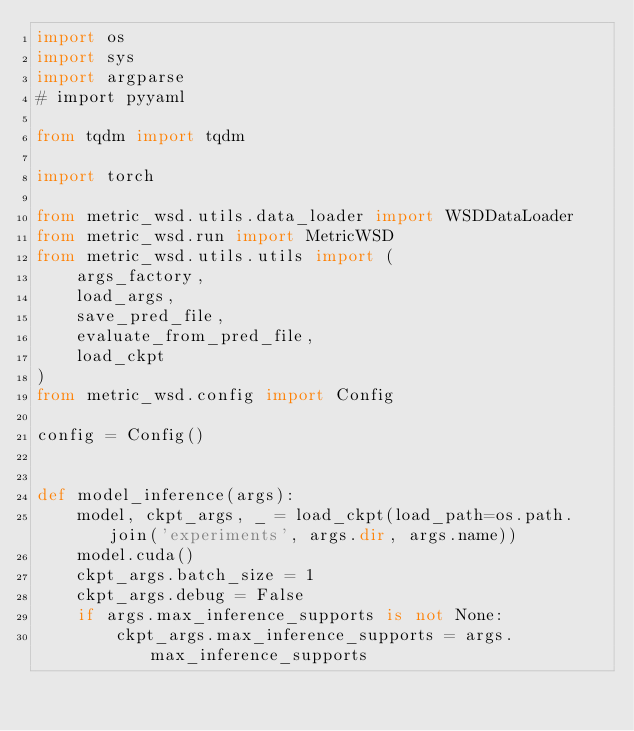<code> <loc_0><loc_0><loc_500><loc_500><_Python_>import os
import sys
import argparse
# import pyyaml

from tqdm import tqdm

import torch

from metric_wsd.utils.data_loader import WSDDataLoader
from metric_wsd.run import MetricWSD
from metric_wsd.utils.utils import (
    args_factory,
    load_args,
    save_pred_file,
    evaluate_from_pred_file,
    load_ckpt
)
from metric_wsd.config import Config

config = Config()


def model_inference(args):
    model, ckpt_args, _ = load_ckpt(load_path=os.path.join('experiments', args.dir, args.name))
    model.cuda()
    ckpt_args.batch_size = 1
    ckpt_args.debug = False
    if args.max_inference_supports is not None:
        ckpt_args.max_inference_supports = args.max_inference_supports
</code> 